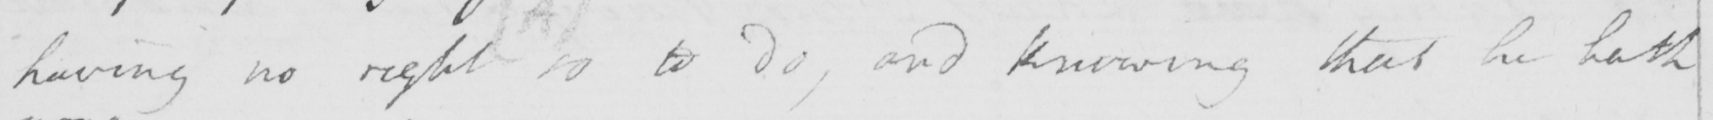Can you read and transcribe this handwriting? having no right  ( A )  so to do , and knowing that he hath 